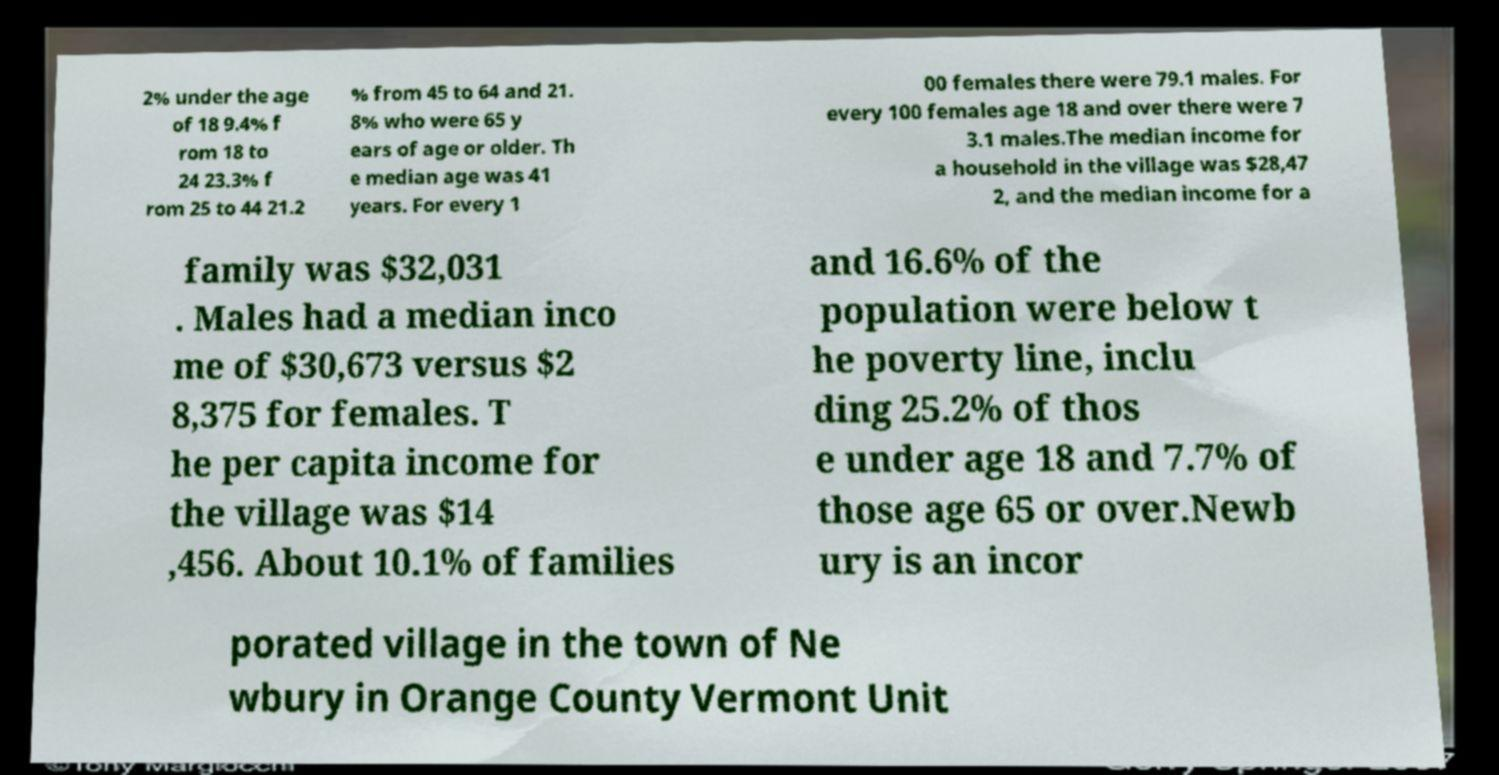There's text embedded in this image that I need extracted. Can you transcribe it verbatim? 2% under the age of 18 9.4% f rom 18 to 24 23.3% f rom 25 to 44 21.2 % from 45 to 64 and 21. 8% who were 65 y ears of age or older. Th e median age was 41 years. For every 1 00 females there were 79.1 males. For every 100 females age 18 and over there were 7 3.1 males.The median income for a household in the village was $28,47 2, and the median income for a family was $32,031 . Males had a median inco me of $30,673 versus $2 8,375 for females. T he per capita income for the village was $14 ,456. About 10.1% of families and 16.6% of the population were below t he poverty line, inclu ding 25.2% of thos e under age 18 and 7.7% of those age 65 or over.Newb ury is an incor porated village in the town of Ne wbury in Orange County Vermont Unit 